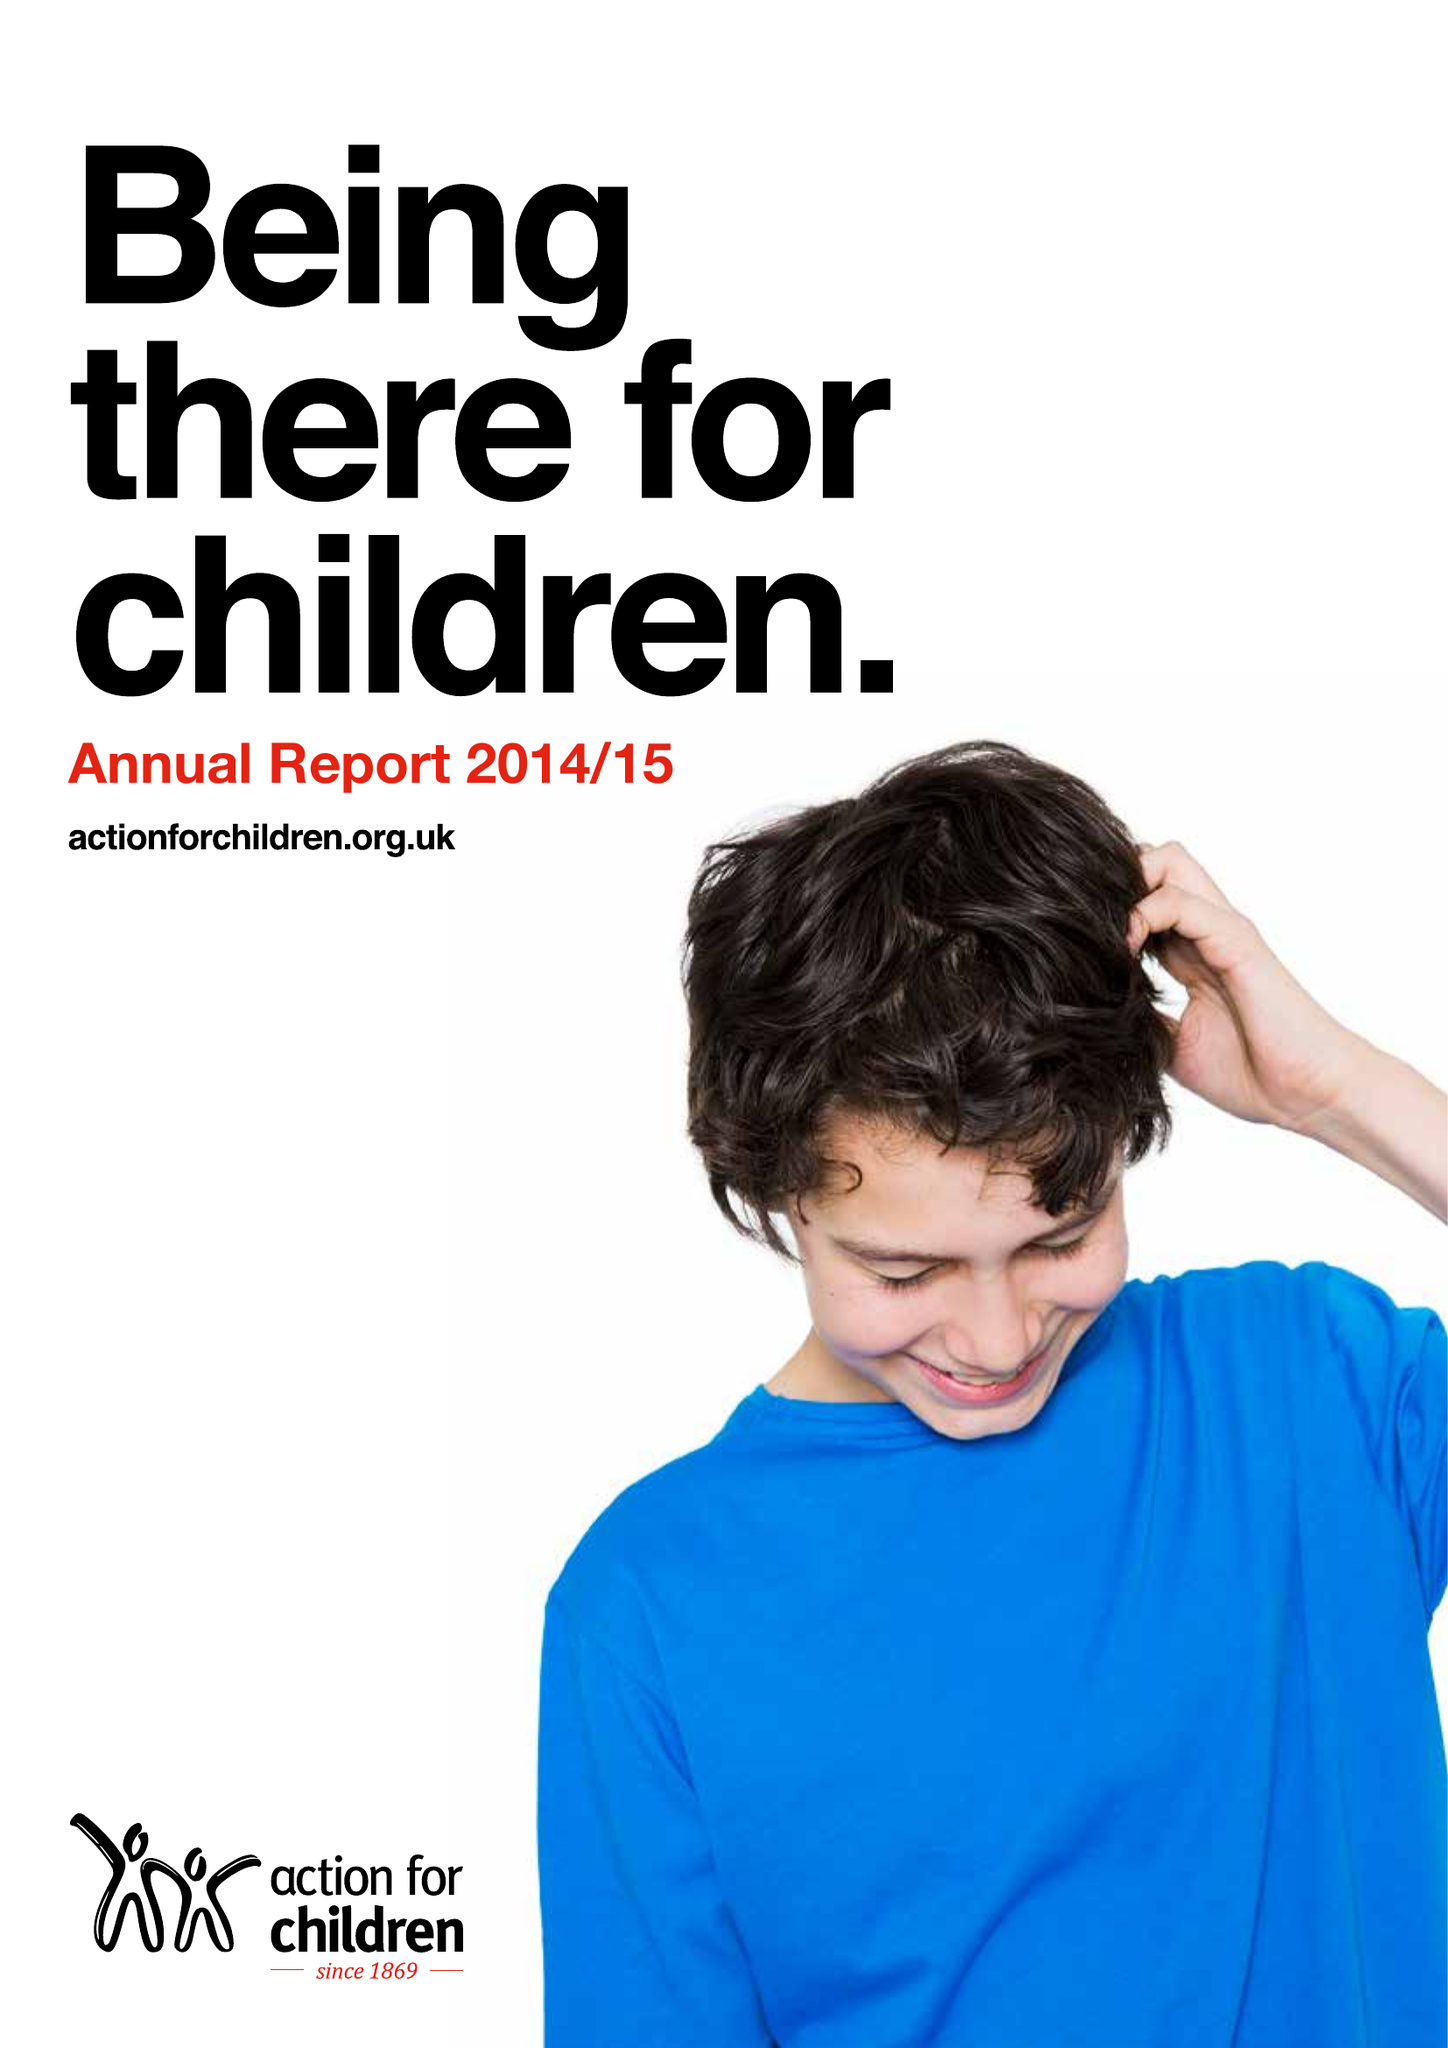What is the value for the address__postcode?
Answer the question using a single word or phrase. WD18 8AG 